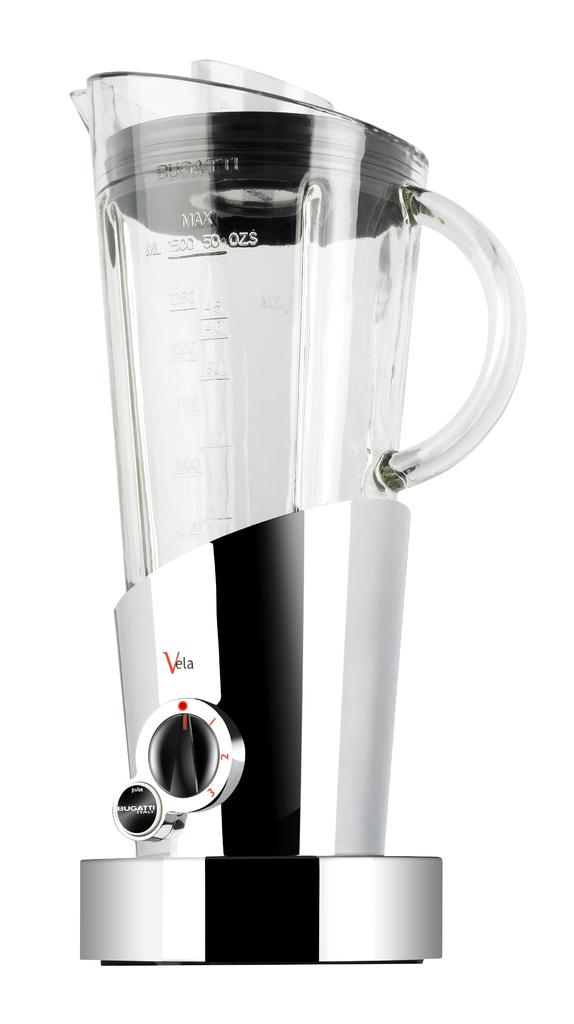Can you describe the main subject or objects in the image? Unfortunately, there are no specific facts provided about the image, so it is impossible to describe the main subject or objects. What type of jeans are being baked in the oven in the image? There is no image provided, and there is no mention of jeans or an oven, so this question cannot be answered. 